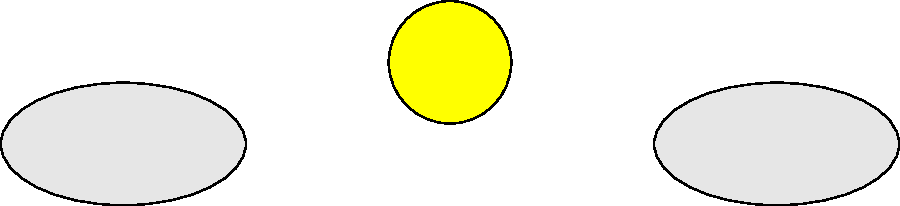In this captivating water cycle flowchart, which process is represented by the arrow moving from the ocean back up to the clouds? Let's follow the water cycle step-by-step to identify the process in question:

1. The cycle begins with the sun providing energy to the system.
2. This energy causes water to evaporate from various sources, including the ocean, rivers, and land.
3. The evaporated water rises into the atmosphere, where it cools and condenses to form clouds.
4. When conditions are right, the water in the clouds falls as precipitation (rain, snow, etc.).
5. This water is then collected in various bodies like rivers, which eventually flow back into the ocean.
6. The cycle then repeats, with water from the ocean once again rising into the atmosphere.

The arrow moving from the ocean back up to the clouds represents this last step - the evaporation of water from the ocean surface. This process is driven by the sun's energy, which heats the water and causes it to change from a liquid to a gas state.

This evaporation process is crucial to the water cycle as it replenishes the atmospheric moisture, allowing the cycle to continue indefinitely.
Answer: Evaporation 